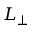<formula> <loc_0><loc_0><loc_500><loc_500>L _ { \perp }</formula> 